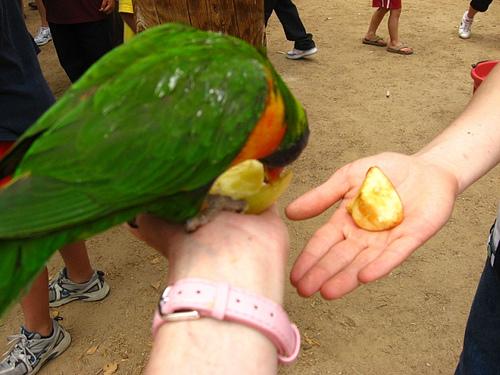What color is the watchband?
Quick response, please. Pink. What kind of bird is this?
Answer briefly. Parrot. How many birds?
Quick response, please. 1. 